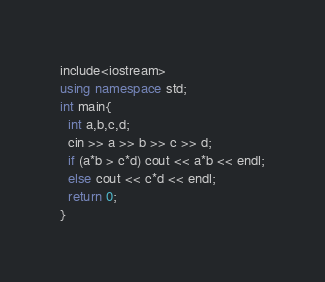Convert code to text. <code><loc_0><loc_0><loc_500><loc_500><_C++_>include<iostream>
using namespace std;
int main{
  int a,b,c,d;
  cin >> a >> b >> c >> d;
  if (a*b > c*d) cout << a*b << endl;
  else cout << c*d << endl;
  return 0;
}</code> 